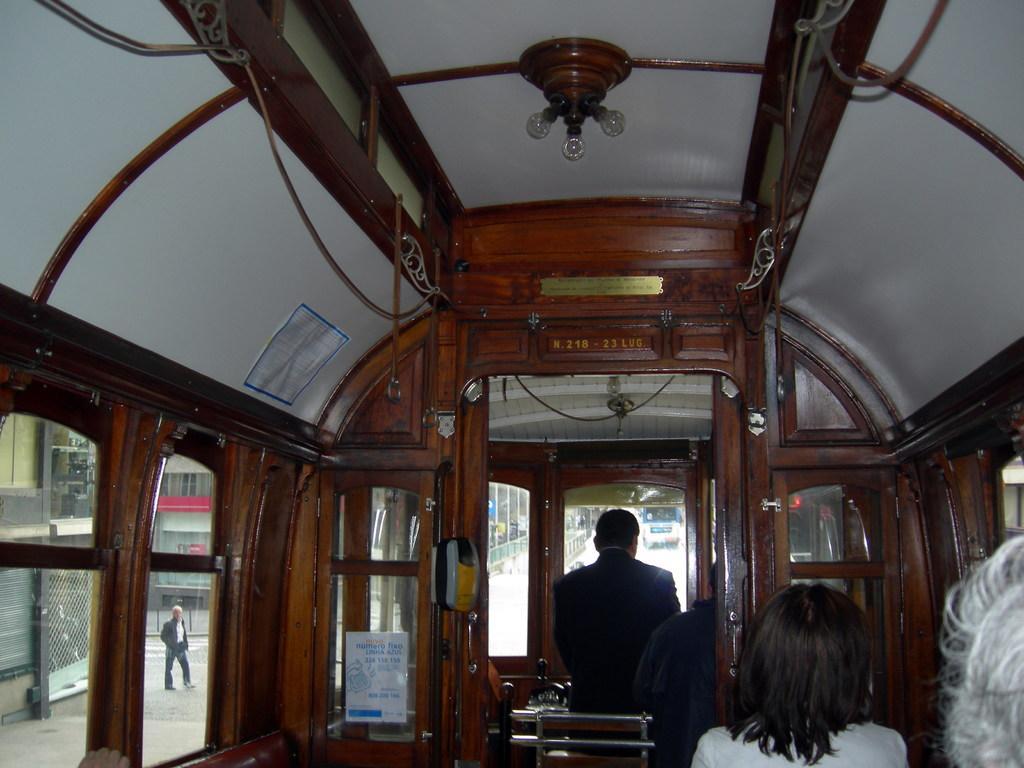In one or two sentences, can you explain what this image depicts? In the middle of the image few people are sitting on a vehicle. Through the glass window we can see a person standing. Behind him there are some buildings. Through the windshield we can see some vehicles and fencing. Top of the image there is roof and lights. 